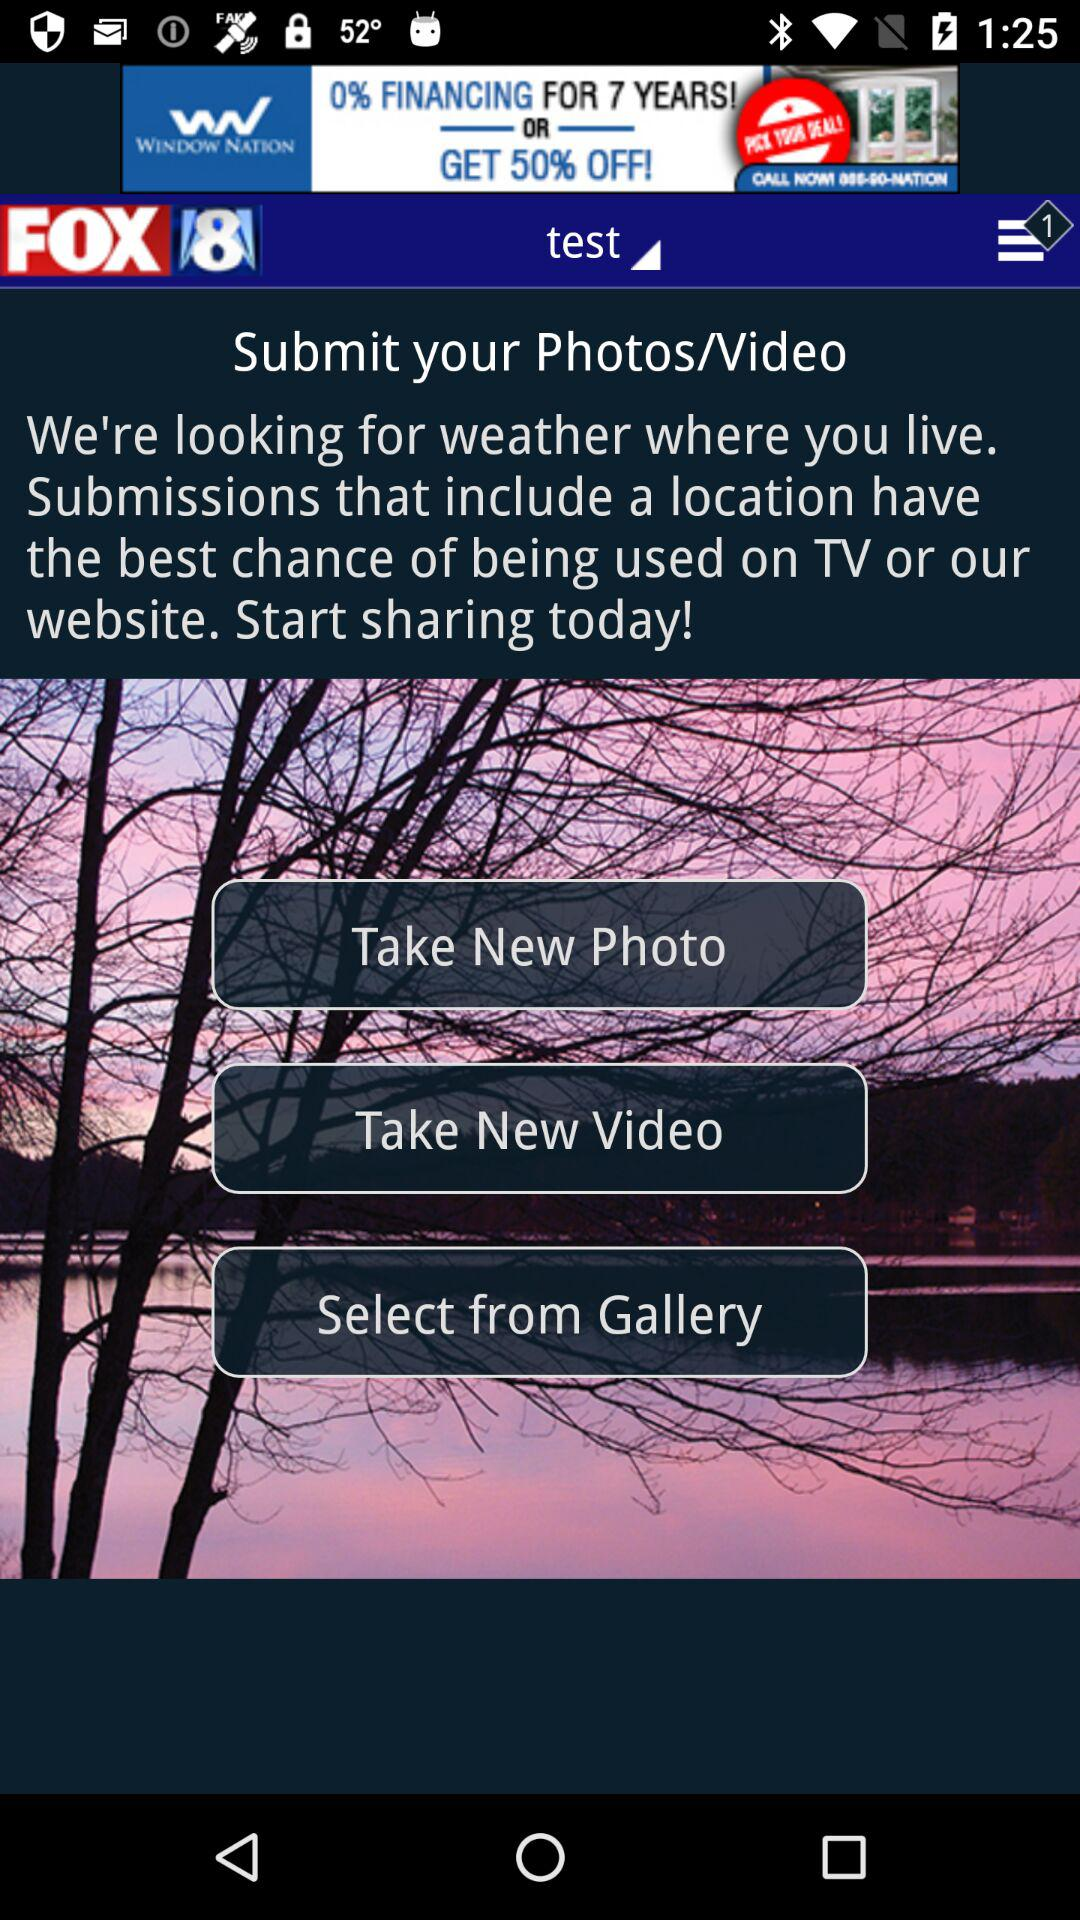What is the name of the application? The name of the application is "FOX 8". 